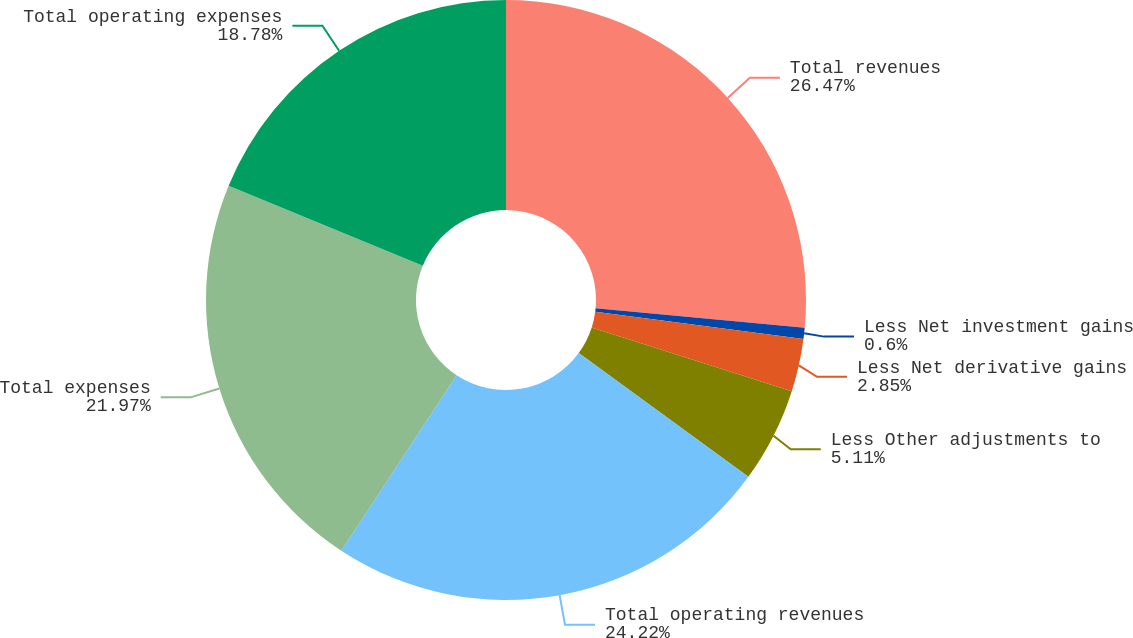Convert chart to OTSL. <chart><loc_0><loc_0><loc_500><loc_500><pie_chart><fcel>Total revenues<fcel>Less Net investment gains<fcel>Less Net derivative gains<fcel>Less Other adjustments to<fcel>Total operating revenues<fcel>Total expenses<fcel>Total operating expenses<nl><fcel>26.47%<fcel>0.6%<fcel>2.85%<fcel>5.11%<fcel>24.22%<fcel>21.97%<fcel>18.78%<nl></chart> 